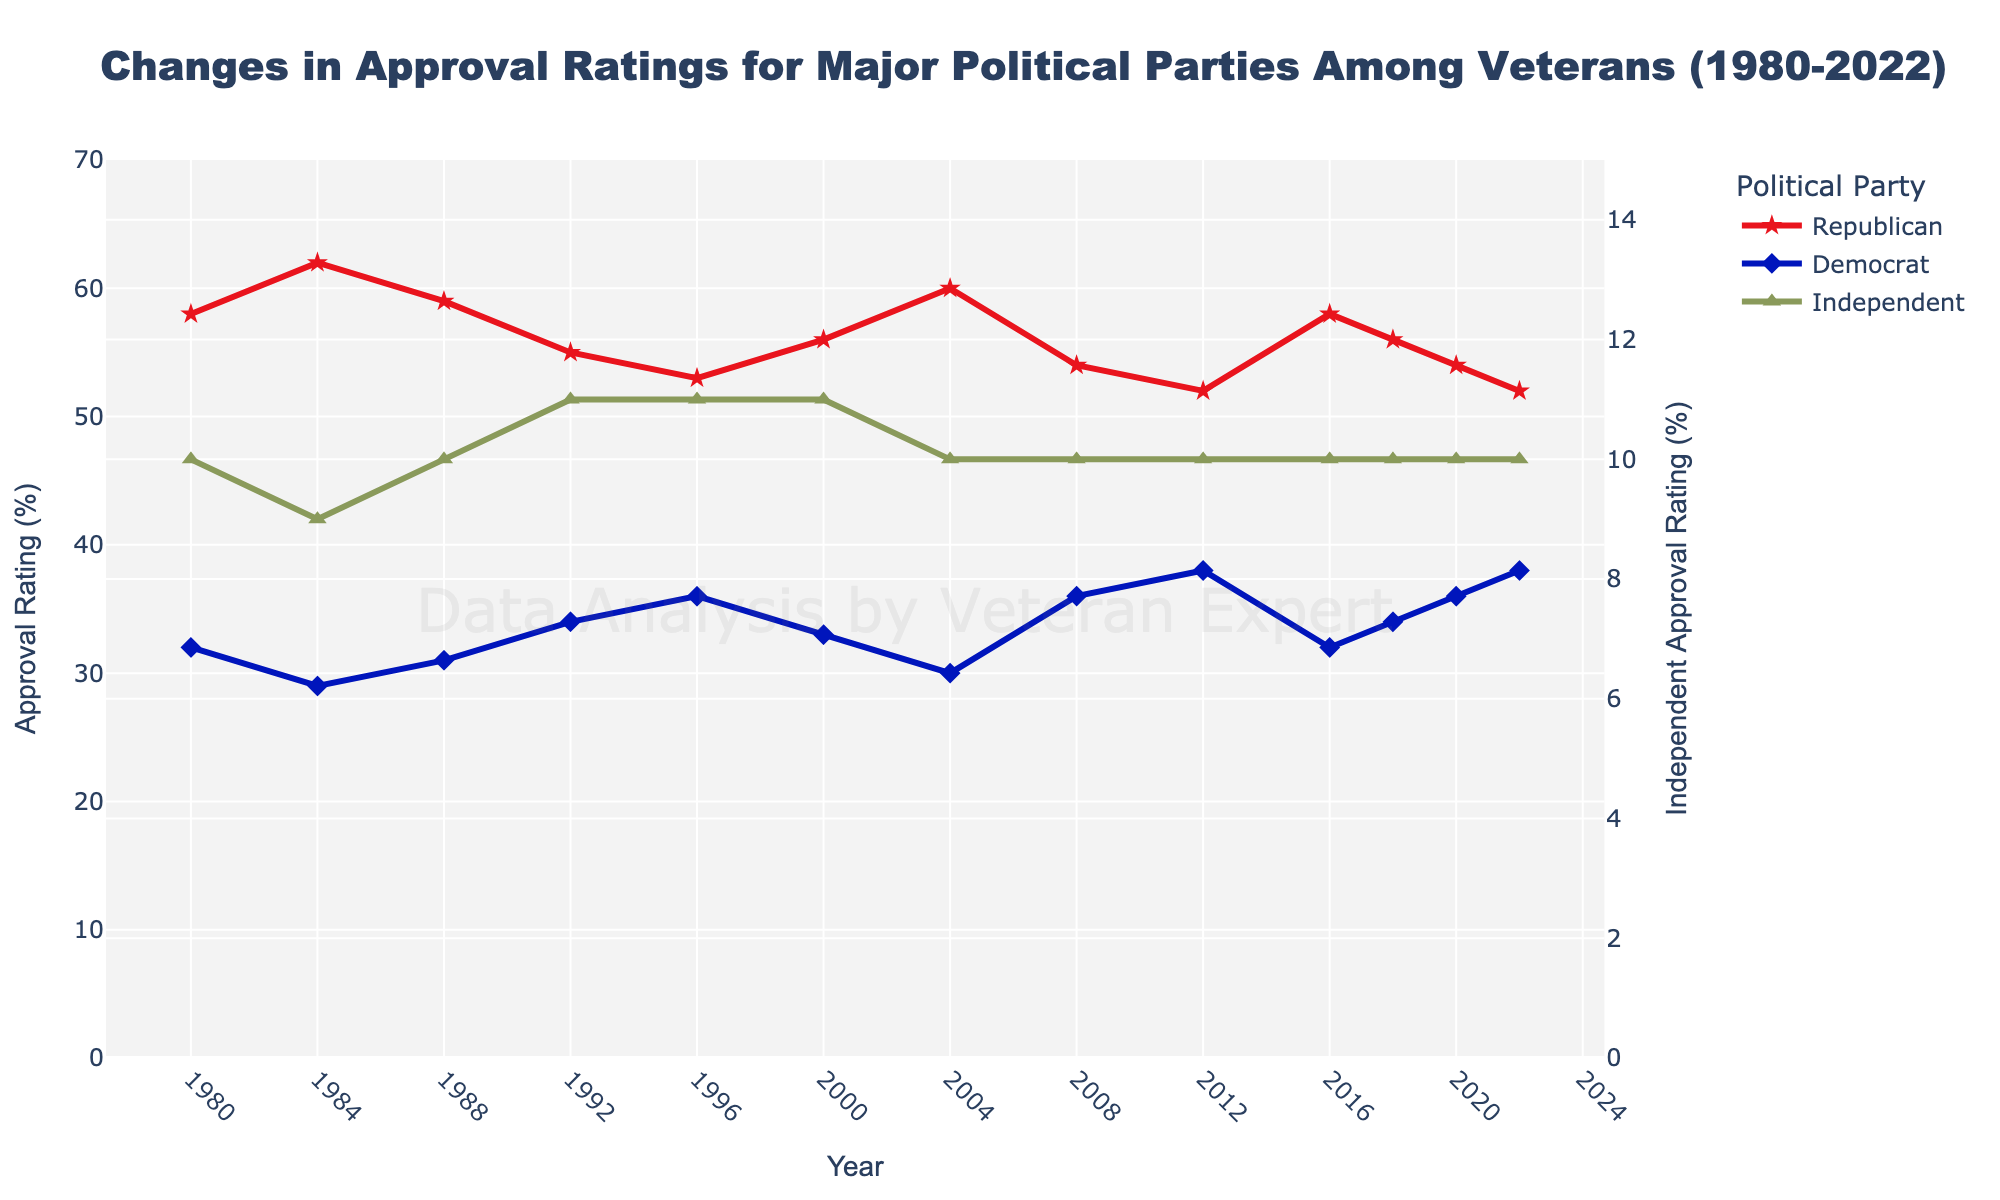What's the approval rating trend for Republicans among veterans from 1980 to 2022? The chart shows the approval rating for Republicans indicated by a red line with a star marker. Starting at 58% in 1980, it generally fluctuates but follows a slight downward trend, ending at 52% in 2022.
Answer: Slight downward trend Which year did Democrats have their lowest approval rating among veterans? The blue line with a diamond marker represents Democrat approval ratings. The lowest point appears to be in 1984 with a 29% approval rating.
Answer: 1984 In which year are the approval ratings for Republicans and Democrats closest to each other? Compare the red line and blue line in each year. The year where the ratings are closest is 1992, where Republicans have 55% and Democrats have 34%, making a 21% difference.
Answer: 1992 Between 2000 and 2012, how did the approval rating change for Independents among veterans? The green line with a triangle-up marker represents Independents. From 2000 to 2012, the approval rating for Independents remains constant at 10%.
Answer: Constant What's the average approval rating of the Democratic Party among veterans from 2008 to 2022? Adding the Democratic approval ratings from 2008 to 2022 (36 + 38 + 32 + 34 + 36 + 38) gives a total of 214. Dividing by the number of data points (6) results in an average rating of 35.67%.
Answer: 35.67% Which political party had a higher approval rating more frequently from 1980 to 2022, Republicans or Democrats? By visual assessment of the red and blue lines, it is clear that the red line (Republicans) is above the blue line (Democrats) in most of the recorded years.
Answer: Republicans How much did the approval rating for Republicans change from their highest point to their lowest point? The highest approval rating for Republicans is 62% (1984), and the lowest is 52% (2012, 2022), resulting in a change of 62 - 52 = 10%.
Answer: 10% In which year(s) did the approval rating for Independents increase compared to the previous data point? Checking the green line, the only increase occurs from 1984 (9%) to 1988 (10%).
Answer: 1988 